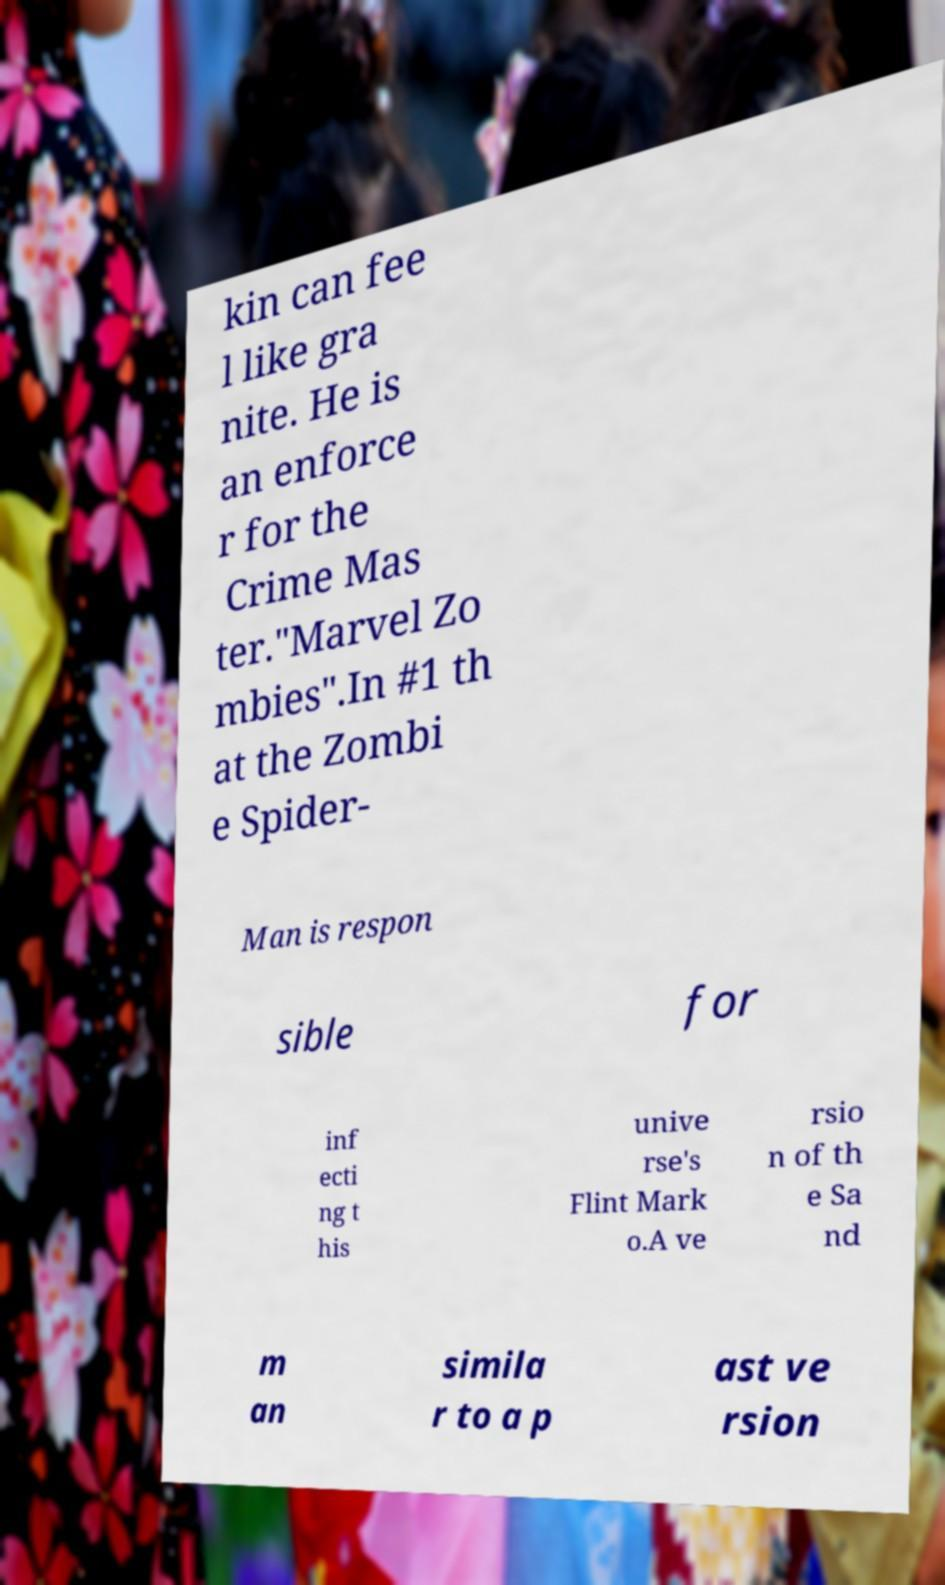Can you read and provide the text displayed in the image?This photo seems to have some interesting text. Can you extract and type it out for me? kin can fee l like gra nite. He is an enforce r for the Crime Mas ter."Marvel Zo mbies".In #1 th at the Zombi e Spider- Man is respon sible for inf ecti ng t his unive rse's Flint Mark o.A ve rsio n of th e Sa nd m an simila r to a p ast ve rsion 